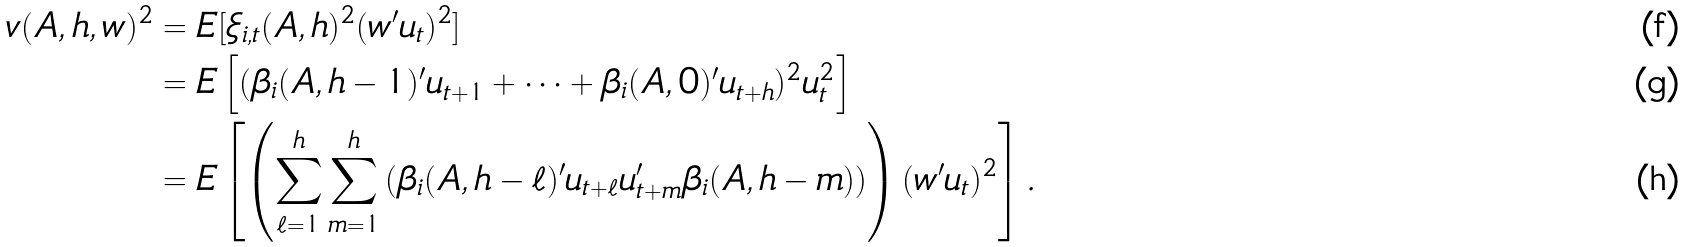<formula> <loc_0><loc_0><loc_500><loc_500>v ( A , h , w ) ^ { 2 } & = E [ \xi _ { i , t } ( A , h ) ^ { 2 } ( w ^ { \prime } u _ { t } ) ^ { 2 } ] \\ & = E \left [ ( \beta _ { i } ( A , h - 1 ) ^ { \prime } u _ { t + 1 } + \dots + \beta _ { i } ( A , 0 ) ^ { \prime } u _ { t + h } ) ^ { 2 } u _ { t } ^ { 2 } \right ] \\ & = E \left [ \left ( \sum _ { \ell = 1 } ^ { h } \sum _ { m = 1 } ^ { h } \left ( \beta _ { i } ( A , h - \ell ) ^ { \prime } u _ { t + \ell } u ^ { \prime } _ { t + m } \beta _ { i } ( A , h - m ) \right ) \right ) ( w ^ { \prime } u _ { t } ) ^ { 2 } \right ] .</formula> 